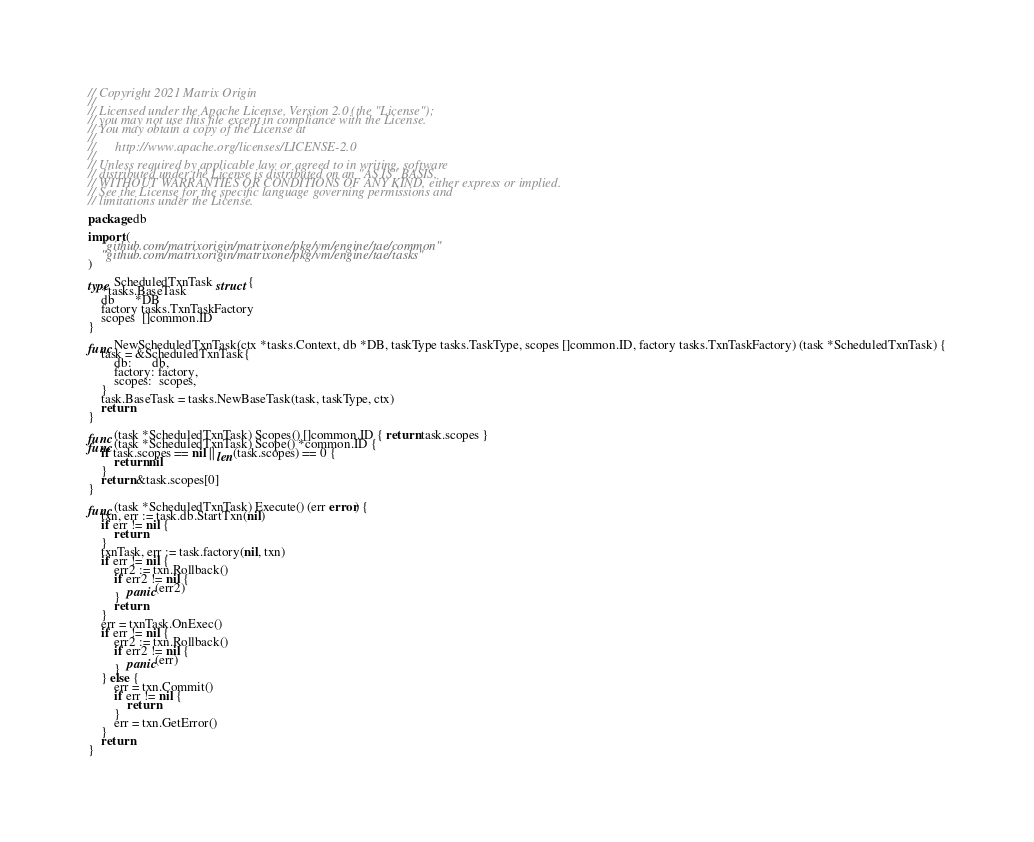Convert code to text. <code><loc_0><loc_0><loc_500><loc_500><_Go_>// Copyright 2021 Matrix Origin
//
// Licensed under the Apache License, Version 2.0 (the "License");
// you may not use this file except in compliance with the License.
// You may obtain a copy of the License at
//
//      http://www.apache.org/licenses/LICENSE-2.0
//
// Unless required by applicable law or agreed to in writing, software
// distributed under the License is distributed on an "AS IS" BASIS,
// WITHOUT WARRANTIES OR CONDITIONS OF ANY KIND, either express or implied.
// See the License for the specific language governing permissions and
// limitations under the License.

package db

import (
	"github.com/matrixorigin/matrixone/pkg/vm/engine/tae/common"
	"github.com/matrixorigin/matrixone/pkg/vm/engine/tae/tasks"
)

type ScheduledTxnTask struct {
	*tasks.BaseTask
	db      *DB
	factory tasks.TxnTaskFactory
	scopes  []common.ID
}

func NewScheduledTxnTask(ctx *tasks.Context, db *DB, taskType tasks.TaskType, scopes []common.ID, factory tasks.TxnTaskFactory) (task *ScheduledTxnTask) {
	task = &ScheduledTxnTask{
		db:      db,
		factory: factory,
		scopes:  scopes,
	}
	task.BaseTask = tasks.NewBaseTask(task, taskType, ctx)
	return
}

func (task *ScheduledTxnTask) Scopes() []common.ID { return task.scopes }
func (task *ScheduledTxnTask) Scope() *common.ID {
	if task.scopes == nil || len(task.scopes) == 0 {
		return nil
	}
	return &task.scopes[0]
}

func (task *ScheduledTxnTask) Execute() (err error) {
	txn, err := task.db.StartTxn(nil)
	if err != nil {
		return
	}
	txnTask, err := task.factory(nil, txn)
	if err != nil {
		err2 := txn.Rollback()
		if err2 != nil {
			panic(err2)
		}
		return
	}
	err = txnTask.OnExec()
	if err != nil {
		err2 := txn.Rollback()
		if err2 != nil {
			panic(err)
		}
	} else {
		err = txn.Commit()
		if err != nil {
			return
		}
		err = txn.GetError()
	}
	return
}
</code> 